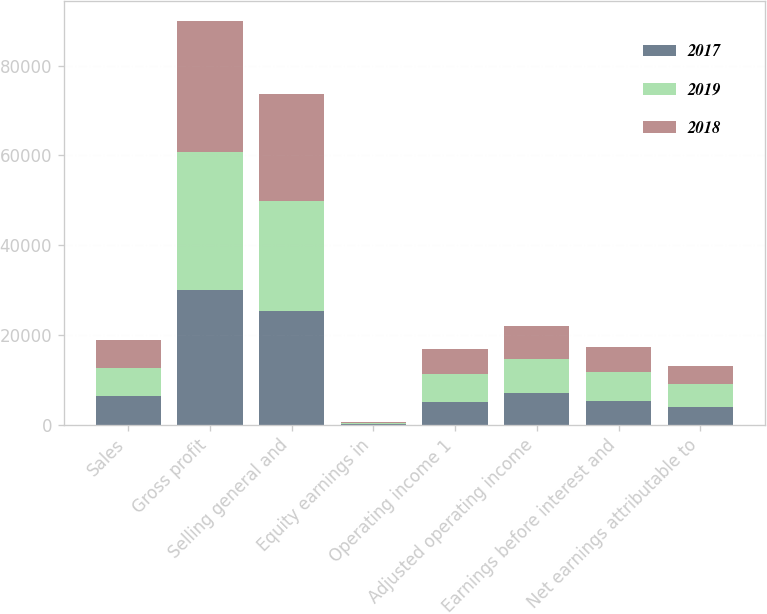Convert chart to OTSL. <chart><loc_0><loc_0><loc_500><loc_500><stacked_bar_chart><ecel><fcel>Sales<fcel>Gross profit<fcel>Selling general and<fcel>Equity earnings in<fcel>Operating income 1<fcel>Adjusted operating income<fcel>Earnings before interest and<fcel>Net earnings attributable to<nl><fcel>2017<fcel>6289<fcel>30076<fcel>25242<fcel>164<fcel>4998<fcel>6942<fcel>5231<fcel>3982<nl><fcel>2019<fcel>6289<fcel>30792<fcel>24694<fcel>191<fcel>6289<fcel>7679<fcel>6591<fcel>5024<nl><fcel>2018<fcel>6289<fcel>29162<fcel>23813<fcel>135<fcel>5484<fcel>7467<fcel>5546<fcel>4078<nl></chart> 